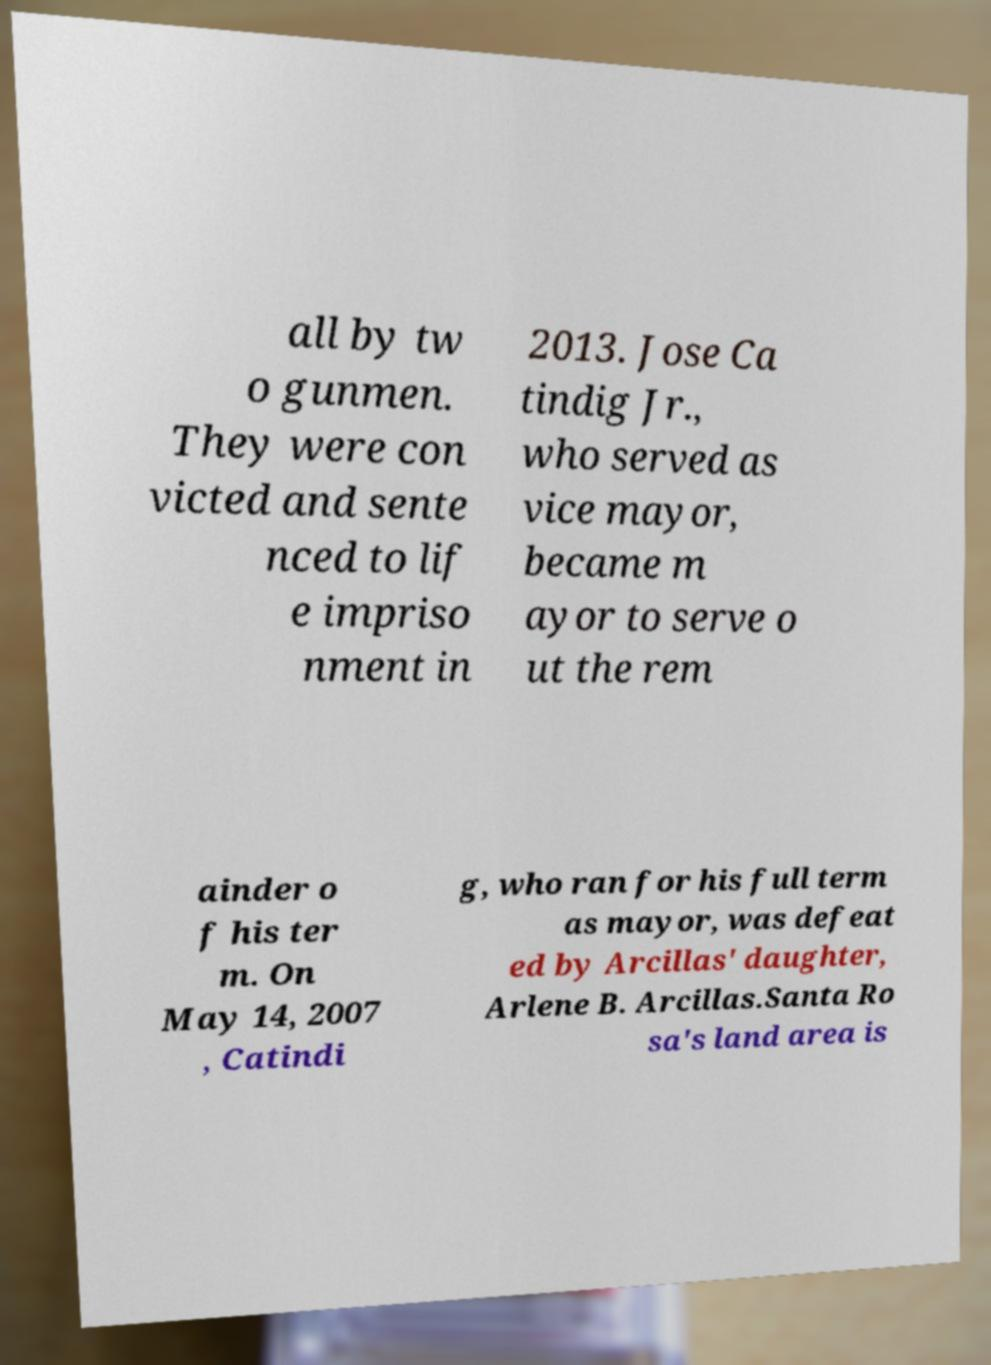I need the written content from this picture converted into text. Can you do that? all by tw o gunmen. They were con victed and sente nced to lif e impriso nment in 2013. Jose Ca tindig Jr., who served as vice mayor, became m ayor to serve o ut the rem ainder o f his ter m. On May 14, 2007 , Catindi g, who ran for his full term as mayor, was defeat ed by Arcillas' daughter, Arlene B. Arcillas.Santa Ro sa's land area is 